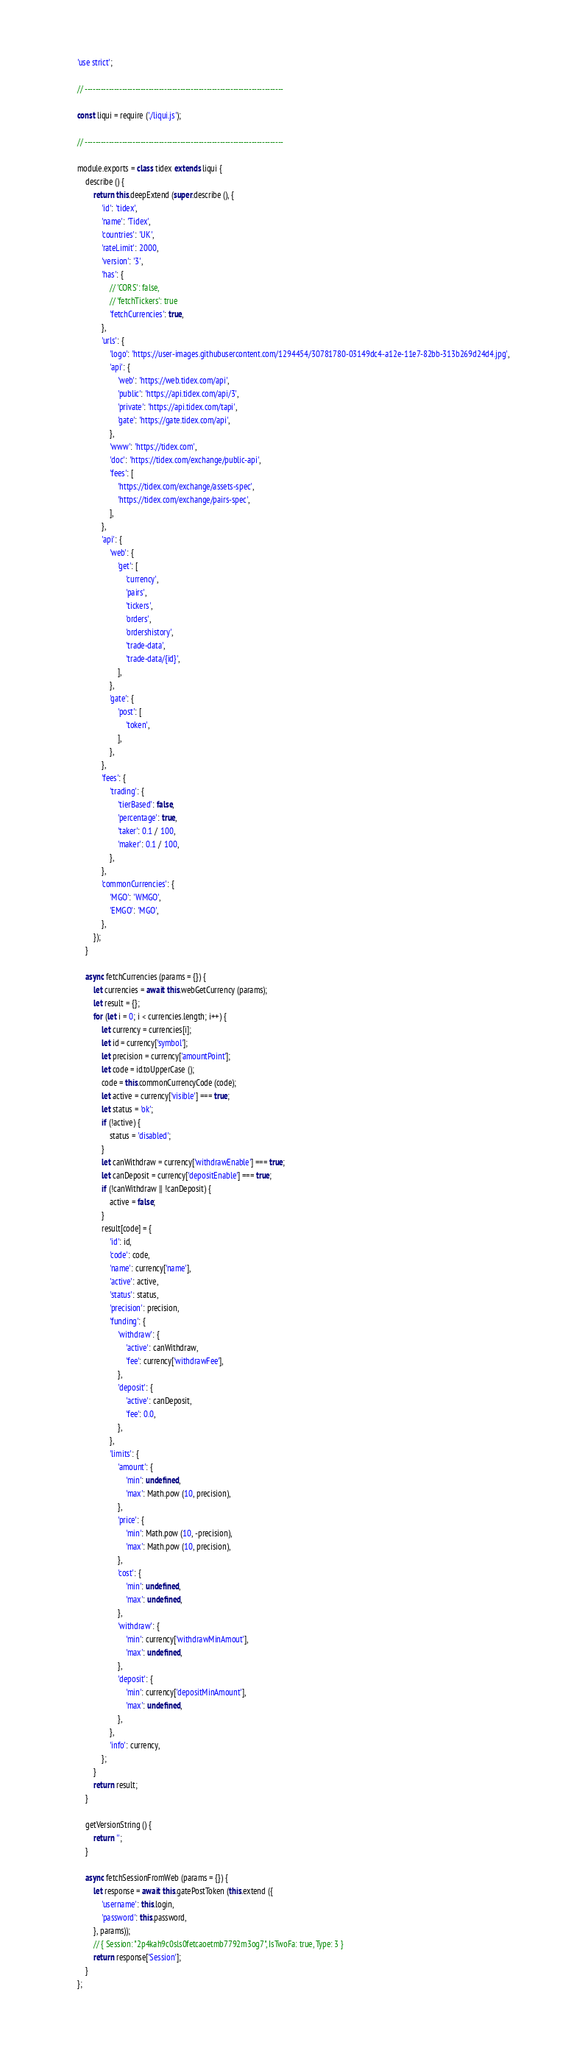Convert code to text. <code><loc_0><loc_0><loc_500><loc_500><_JavaScript_>'use strict';

// ---------------------------------------------------------------------------

const liqui = require ('./liqui.js');

// ---------------------------------------------------------------------------

module.exports = class tidex extends liqui {
    describe () {
        return this.deepExtend (super.describe (), {
            'id': 'tidex',
            'name': 'Tidex',
            'countries': 'UK',
            'rateLimit': 2000,
            'version': '3',
            'has': {
                // 'CORS': false,
                // 'fetchTickers': true
                'fetchCurrencies': true,
            },
            'urls': {
                'logo': 'https://user-images.githubusercontent.com/1294454/30781780-03149dc4-a12e-11e7-82bb-313b269d24d4.jpg',
                'api': {
                    'web': 'https://web.tidex.com/api',
                    'public': 'https://api.tidex.com/api/3',
                    'private': 'https://api.tidex.com/tapi',
                    'gate': 'https://gate.tidex.com/api',
                },
                'www': 'https://tidex.com',
                'doc': 'https://tidex.com/exchange/public-api',
                'fees': [
                    'https://tidex.com/exchange/assets-spec',
                    'https://tidex.com/exchange/pairs-spec',
                ],
            },
            'api': {
                'web': {
                    'get': [
                        'currency',
                        'pairs',
                        'tickers',
                        'orders',
                        'ordershistory',
                        'trade-data',
                        'trade-data/{id}',
                    ],
                },
                'gate': {
                    'post': [
                        'token',
                    ],
                },
            },
            'fees': {
                'trading': {
                    'tierBased': false,
                    'percentage': true,
                    'taker': 0.1 / 100,
                    'maker': 0.1 / 100,
                },
            },
            'commonCurrencies': {
                'MGO': 'WMGO',
                'EMGO': 'MGO',
            },
        });
    }

    async fetchCurrencies (params = {}) {
        let currencies = await this.webGetCurrency (params);
        let result = {};
        for (let i = 0; i < currencies.length; i++) {
            let currency = currencies[i];
            let id = currency['symbol'];
            let precision = currency['amountPoint'];
            let code = id.toUpperCase ();
            code = this.commonCurrencyCode (code);
            let active = currency['visible'] === true;
            let status = 'ok';
            if (!active) {
                status = 'disabled';
            }
            let canWithdraw = currency['withdrawEnable'] === true;
            let canDeposit = currency['depositEnable'] === true;
            if (!canWithdraw || !canDeposit) {
                active = false;
            }
            result[code] = {
                'id': id,
                'code': code,
                'name': currency['name'],
                'active': active,
                'status': status,
                'precision': precision,
                'funding': {
                    'withdraw': {
                        'active': canWithdraw,
                        'fee': currency['withdrawFee'],
                    },
                    'deposit': {
                        'active': canDeposit,
                        'fee': 0.0,
                    },
                },
                'limits': {
                    'amount': {
                        'min': undefined,
                        'max': Math.pow (10, precision),
                    },
                    'price': {
                        'min': Math.pow (10, -precision),
                        'max': Math.pow (10, precision),
                    },
                    'cost': {
                        'min': undefined,
                        'max': undefined,
                    },
                    'withdraw': {
                        'min': currency['withdrawMinAmout'],
                        'max': undefined,
                    },
                    'deposit': {
                        'min': currency['depositMinAmount'],
                        'max': undefined,
                    },
                },
                'info': currency,
            };
        }
        return result;
    }

    getVersionString () {
        return '';
    }

    async fetchSessionFromWeb (params = {}) {
        let response = await this.gatePostToken (this.extend ({
            'username': this.login,
            'password': this.password,
        }, params));
        // { Session: "2p4kah9c0sls0fetcaoetmb7792m3og7", IsTwoFa: true, Type: 3 }
        return response['Session'];
    }
};
</code> 